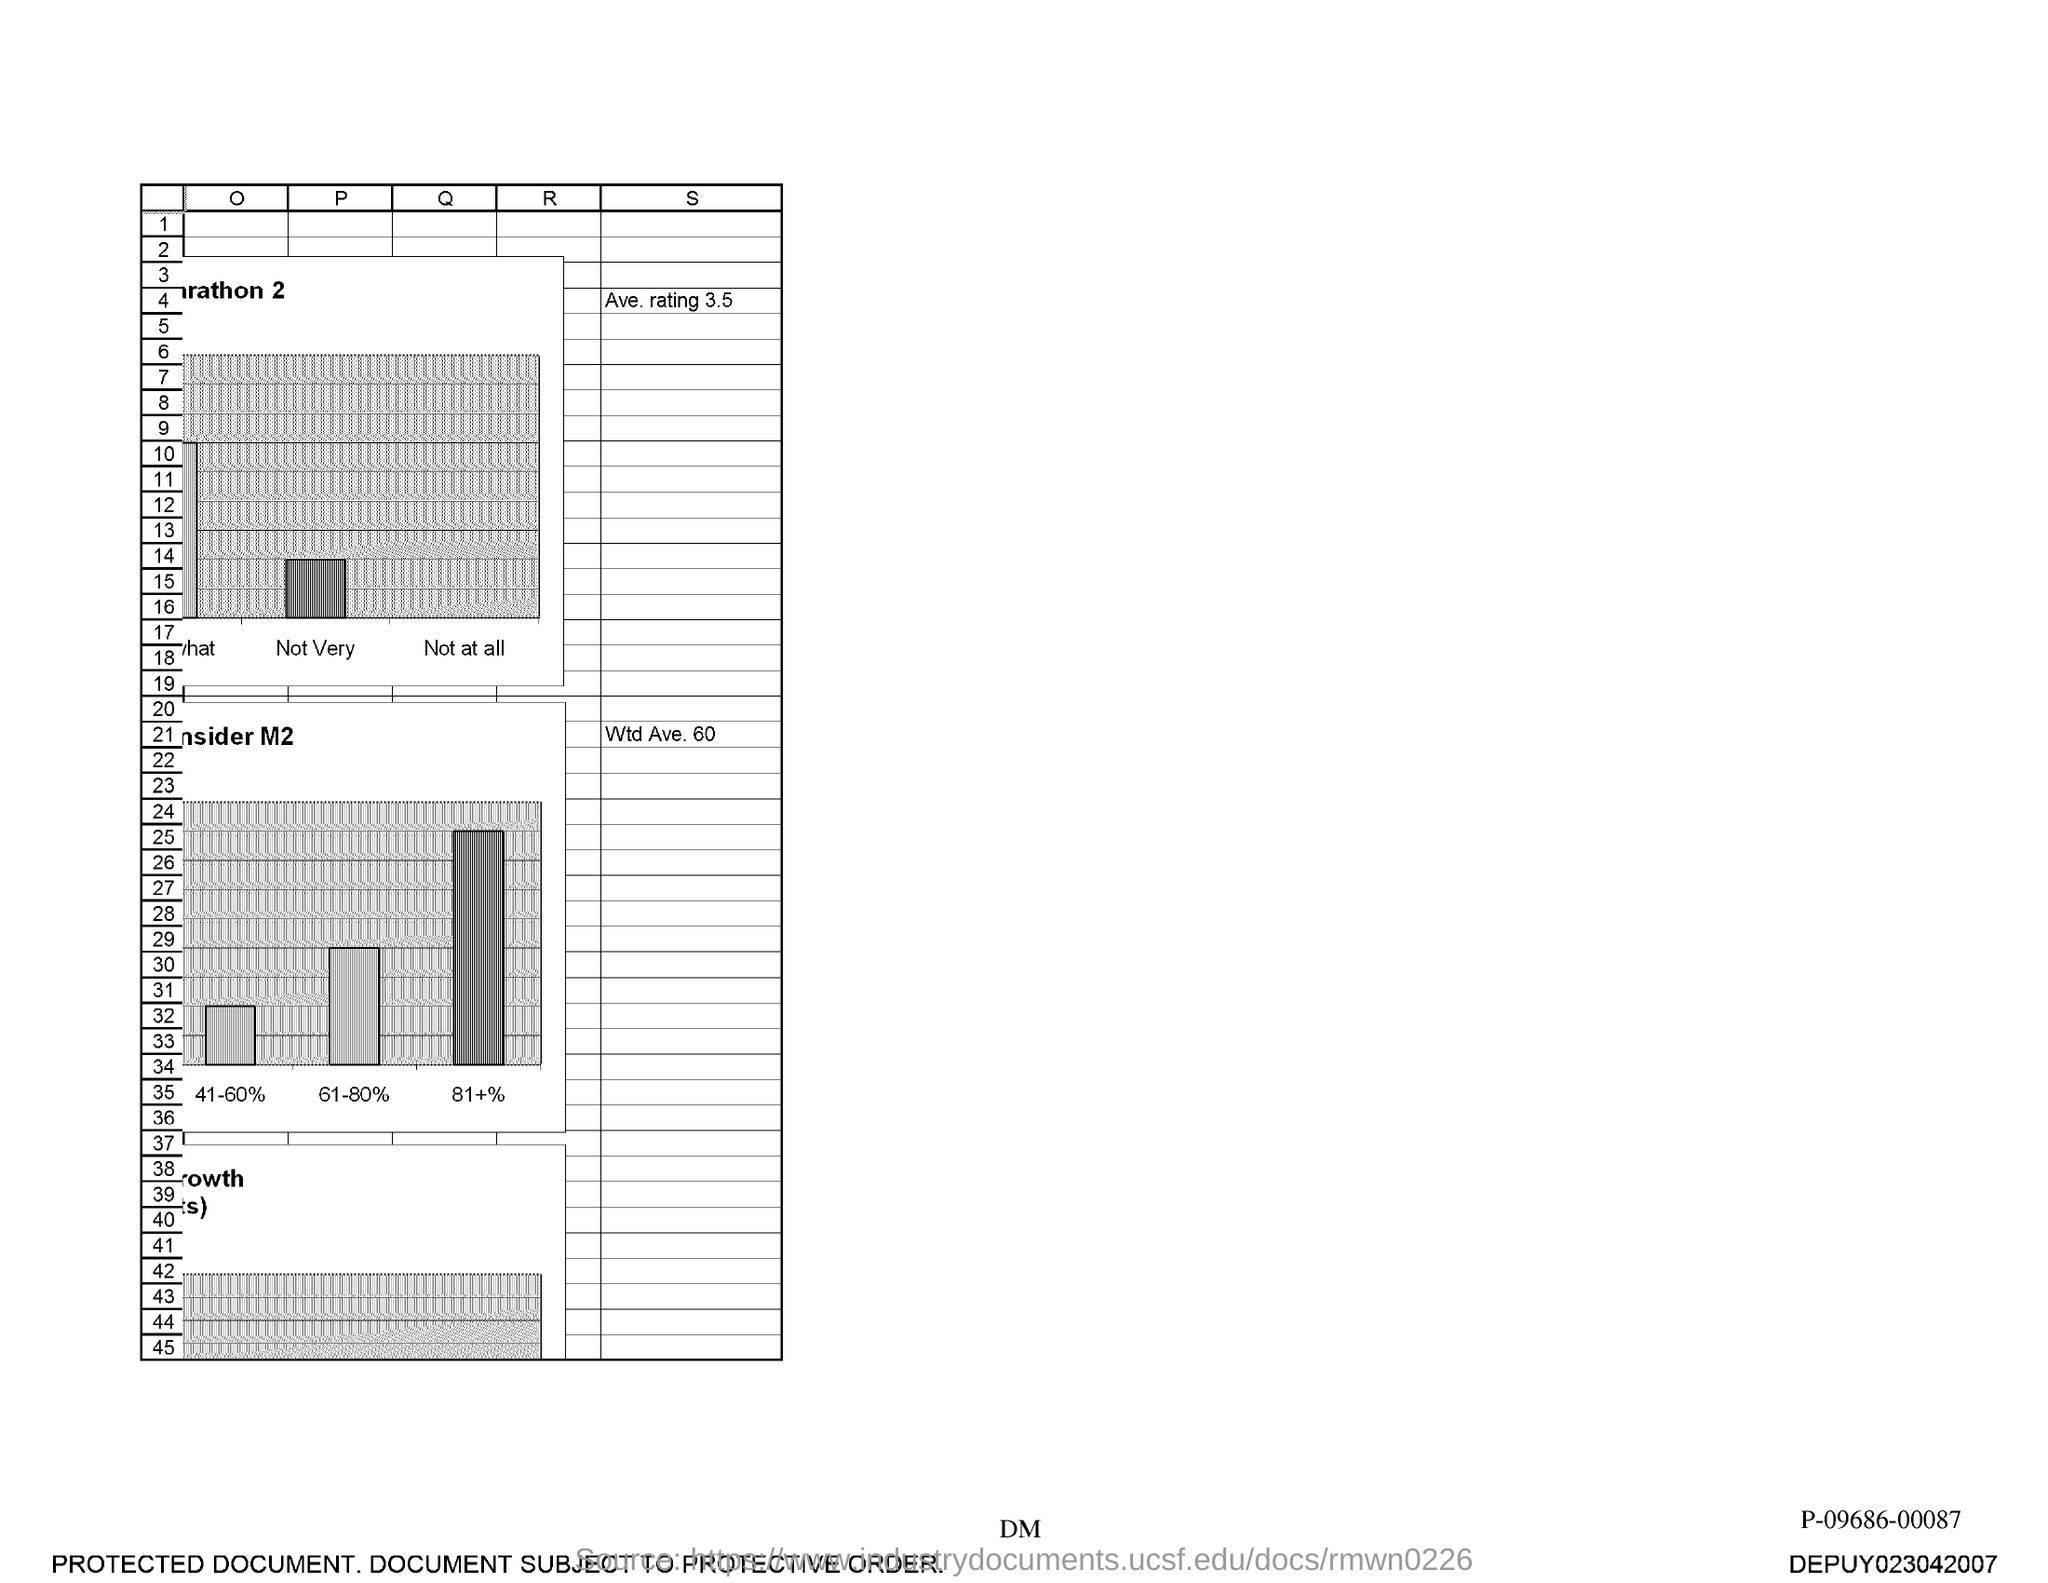Identify some key points in this picture. What is the last number in the first column?" is a question that requires a response. 